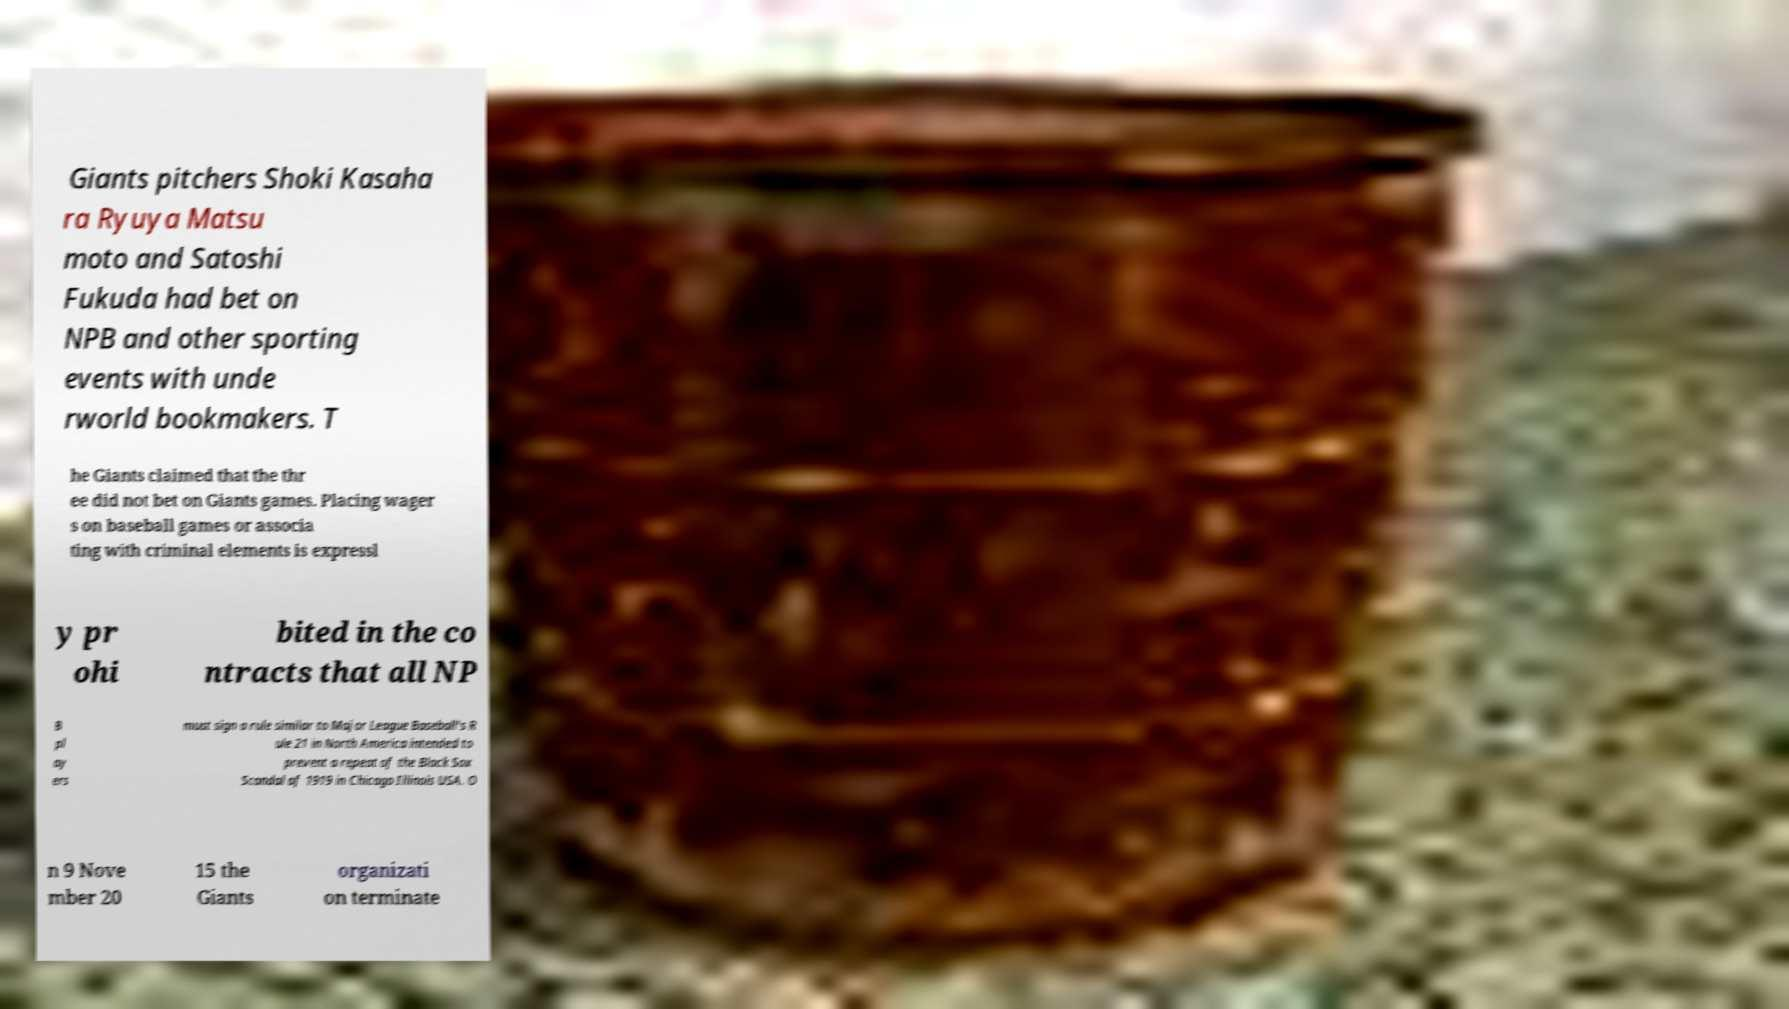Could you assist in decoding the text presented in this image and type it out clearly? Giants pitchers Shoki Kasaha ra Ryuya Matsu moto and Satoshi Fukuda had bet on NPB and other sporting events with unde rworld bookmakers. T he Giants claimed that the thr ee did not bet on Giants games. Placing wager s on baseball games or associa ting with criminal elements is expressl y pr ohi bited in the co ntracts that all NP B pl ay ers must sign a rule similar to Major League Baseball's R ule 21 in North America intended to prevent a repeat of the Black Sox Scandal of 1919 in Chicago Illinois USA. O n 9 Nove mber 20 15 the Giants organizati on terminate 